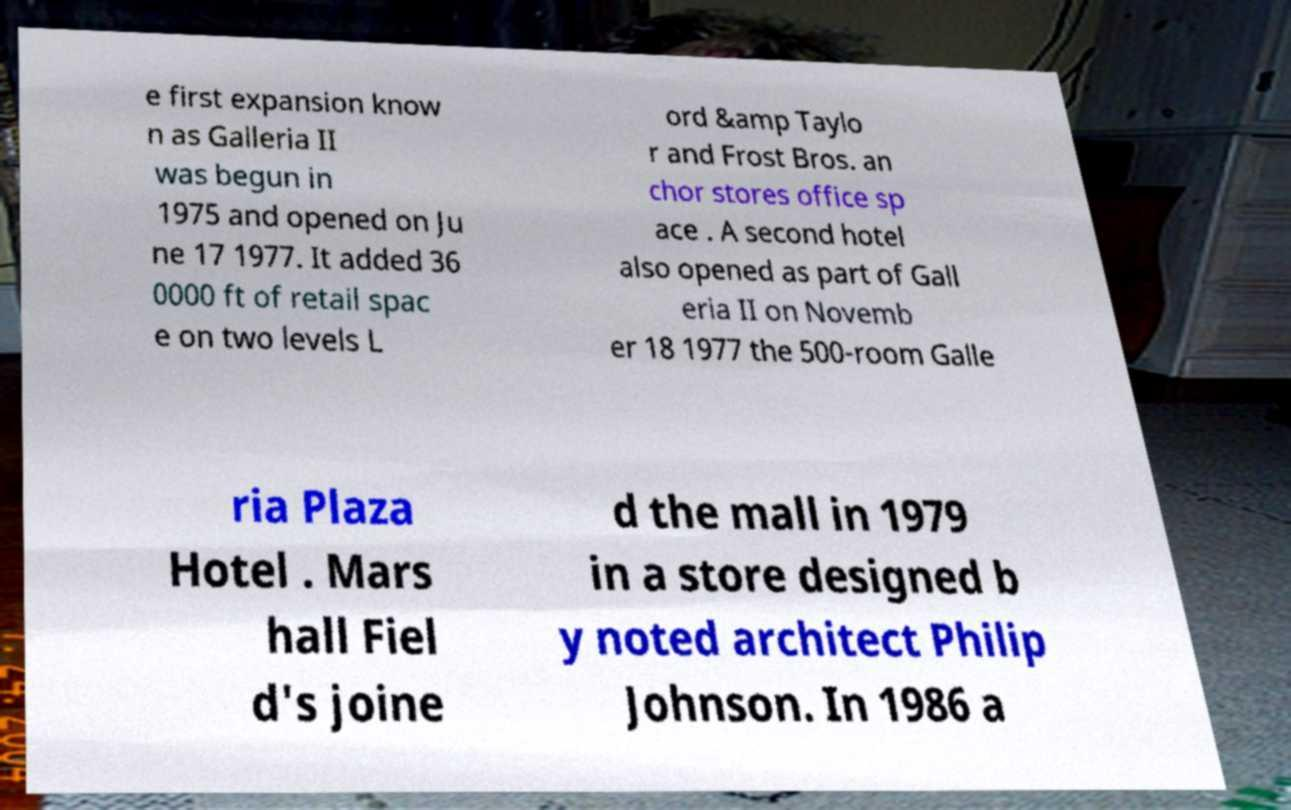What messages or text are displayed in this image? I need them in a readable, typed format. e first expansion know n as Galleria II was begun in 1975 and opened on Ju ne 17 1977. It added 36 0000 ft of retail spac e on two levels L ord &amp Taylo r and Frost Bros. an chor stores office sp ace . A second hotel also opened as part of Gall eria II on Novemb er 18 1977 the 500-room Galle ria Plaza Hotel . Mars hall Fiel d's joine d the mall in 1979 in a store designed b y noted architect Philip Johnson. In 1986 a 